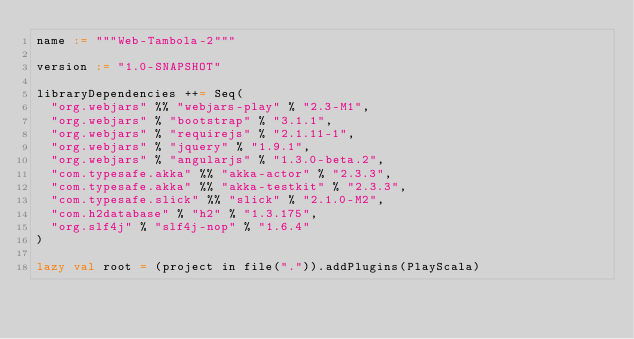<code> <loc_0><loc_0><loc_500><loc_500><_Scala_>name := """Web-Tambola-2"""

version := "1.0-SNAPSHOT"

libraryDependencies ++= Seq(
  "org.webjars" %% "webjars-play" % "2.3-M1",
  "org.webjars" % "bootstrap" % "3.1.1",
  "org.webjars" % "requirejs" % "2.1.11-1",
  "org.webjars" % "jquery" % "1.9.1",
  "org.webjars" % "angularjs" % "1.3.0-beta.2",
  "com.typesafe.akka" %% "akka-actor" % "2.3.3",
  "com.typesafe.akka" %% "akka-testkit" % "2.3.3",
  "com.typesafe.slick" %% "slick" % "2.1.0-M2",
  "com.h2database" % "h2" % "1.3.175",
  "org.slf4j" % "slf4j-nop" % "1.6.4"
)

lazy val root = (project in file(".")).addPlugins(PlayScala)
</code> 